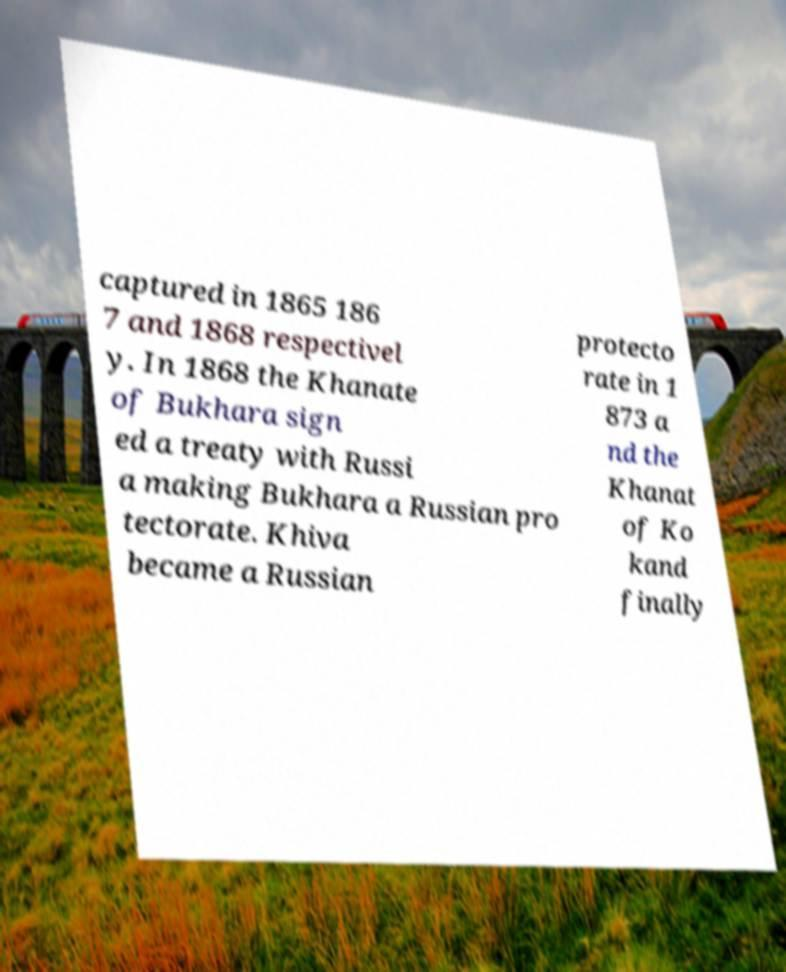Can you accurately transcribe the text from the provided image for me? captured in 1865 186 7 and 1868 respectivel y. In 1868 the Khanate of Bukhara sign ed a treaty with Russi a making Bukhara a Russian pro tectorate. Khiva became a Russian protecto rate in 1 873 a nd the Khanat of Ko kand finally 